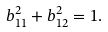Convert formula to latex. <formula><loc_0><loc_0><loc_500><loc_500>b _ { 1 1 } ^ { 2 } + b _ { 1 2 } ^ { 2 } = 1 .</formula> 